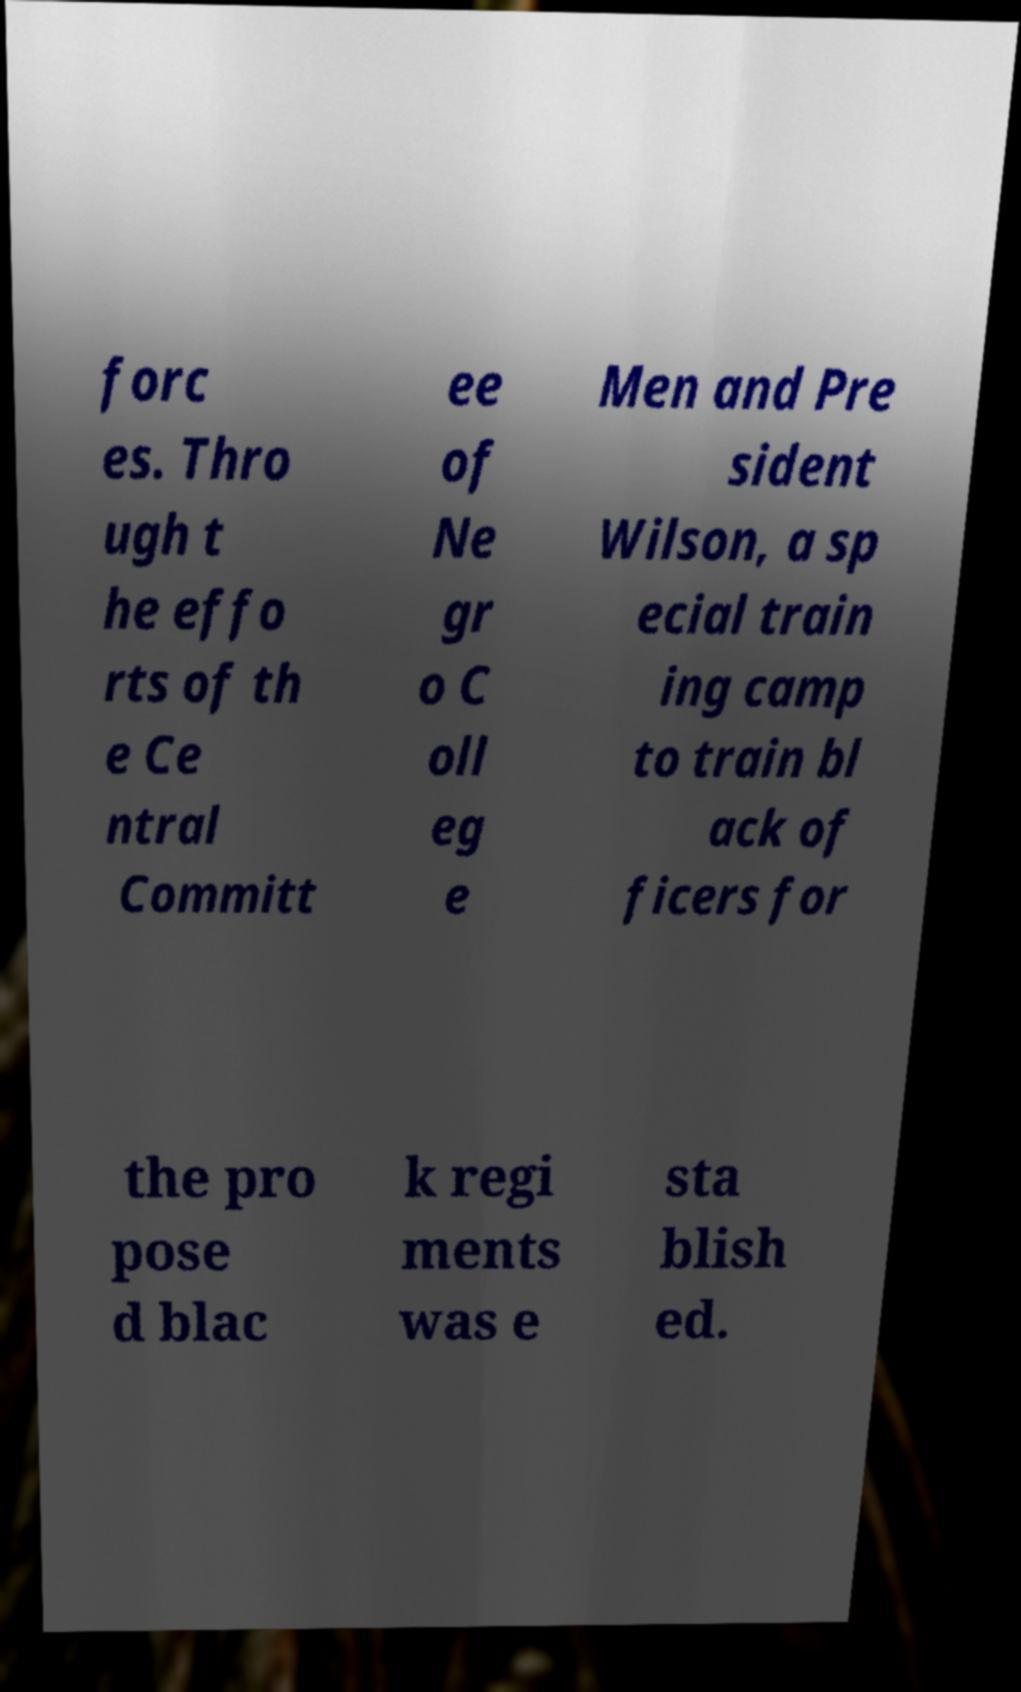Please identify and transcribe the text found in this image. forc es. Thro ugh t he effo rts of th e Ce ntral Committ ee of Ne gr o C oll eg e Men and Pre sident Wilson, a sp ecial train ing camp to train bl ack of ficers for the pro pose d blac k regi ments was e sta blish ed. 